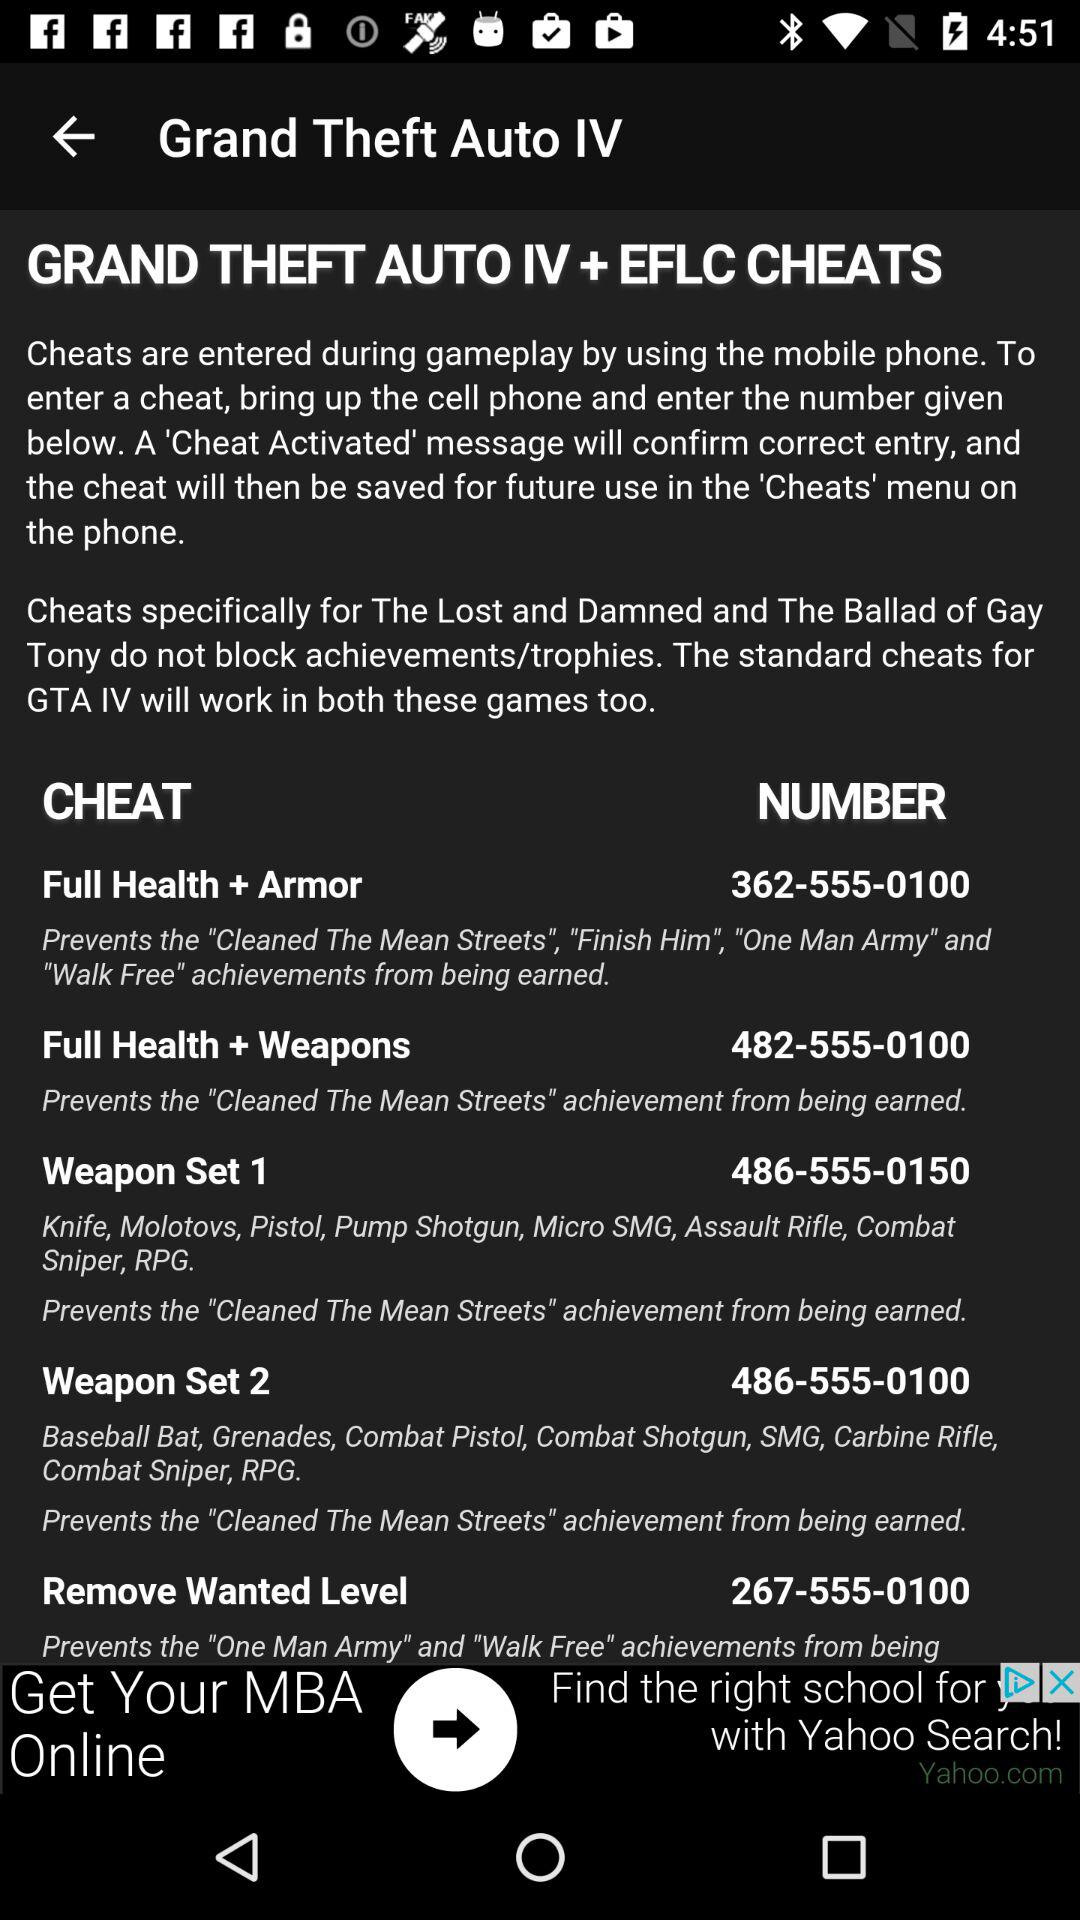How many cheats prevent the 'Cleaned The Mean Streets' achievement from being earned?
Answer the question using a single word or phrase. 4 